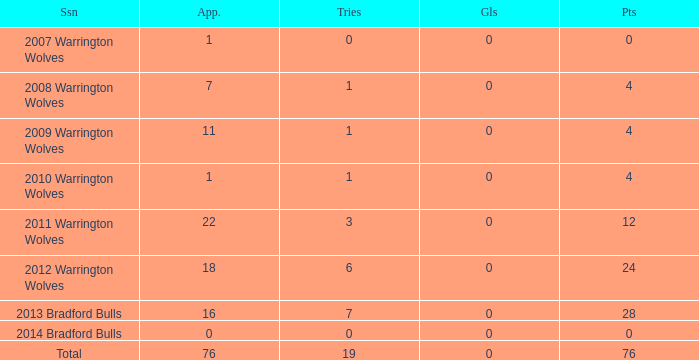What is the average tries for the season 2008 warrington wolves with an appearance more than 7? None. 